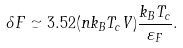<formula> <loc_0><loc_0><loc_500><loc_500>\delta F \simeq 3 . 5 2 ( n k _ { B } T _ { c } V ) \frac { k _ { B } T _ { c } } { \varepsilon _ { F } } .</formula> 